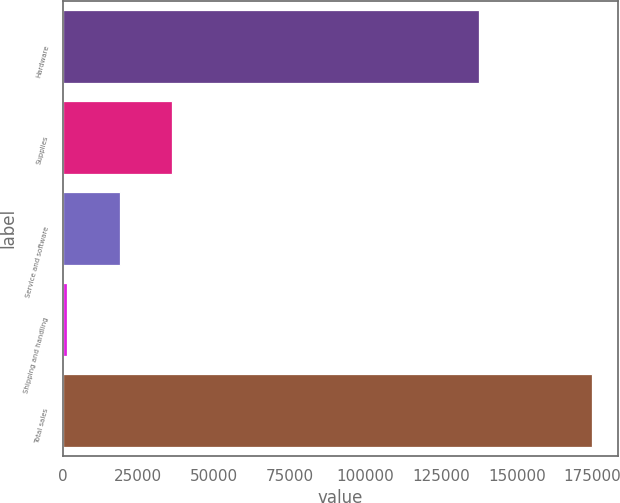<chart> <loc_0><loc_0><loc_500><loc_500><bar_chart><fcel>Hardware<fcel>Supplies<fcel>Service and software<fcel>Shipping and handling<fcel>Total sales<nl><fcel>137529<fcel>36130<fcel>18787<fcel>1444<fcel>174874<nl></chart> 